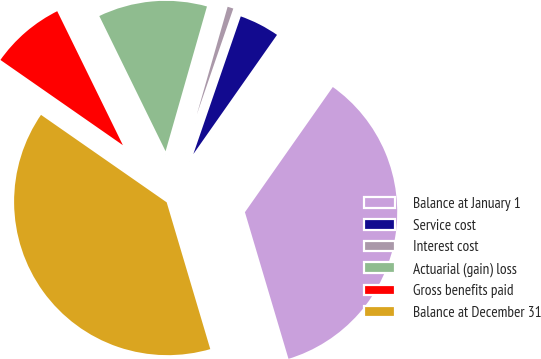Convert chart to OTSL. <chart><loc_0><loc_0><loc_500><loc_500><pie_chart><fcel>Balance at January 1<fcel>Service cost<fcel>Interest cost<fcel>Actuarial (gain) loss<fcel>Gross benefits paid<fcel>Balance at December 31<nl><fcel>35.66%<fcel>4.46%<fcel>0.85%<fcel>11.68%<fcel>8.07%<fcel>39.27%<nl></chart> 